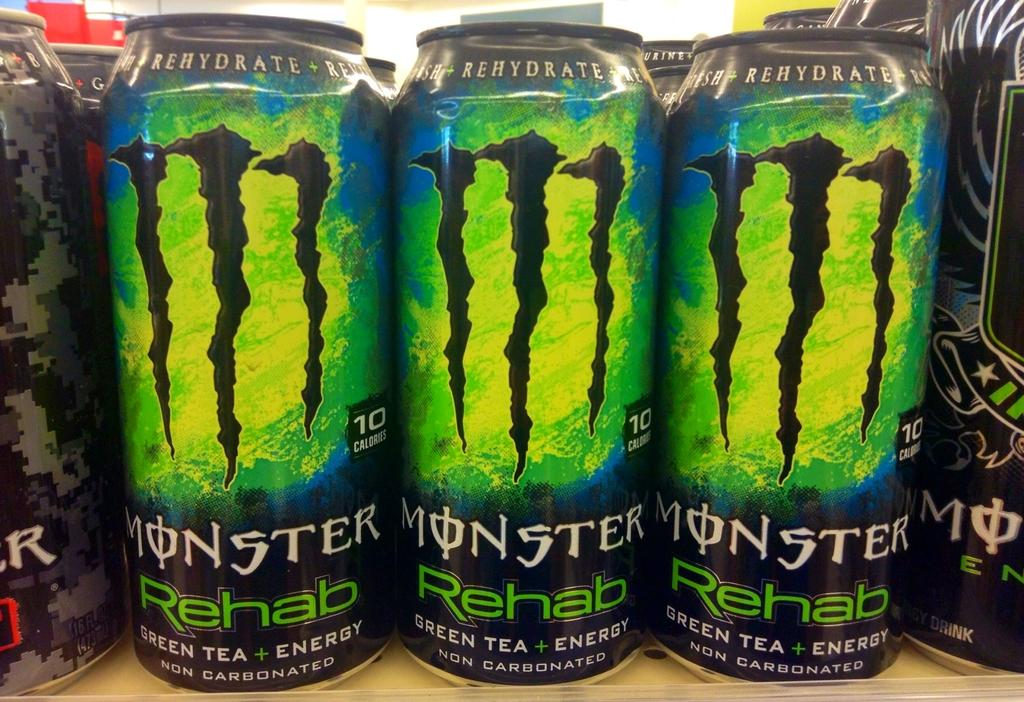<image>
Offer a succinct explanation of the picture presented. Several cans of Monster Rehab, Green tea plus energy are shown together. 